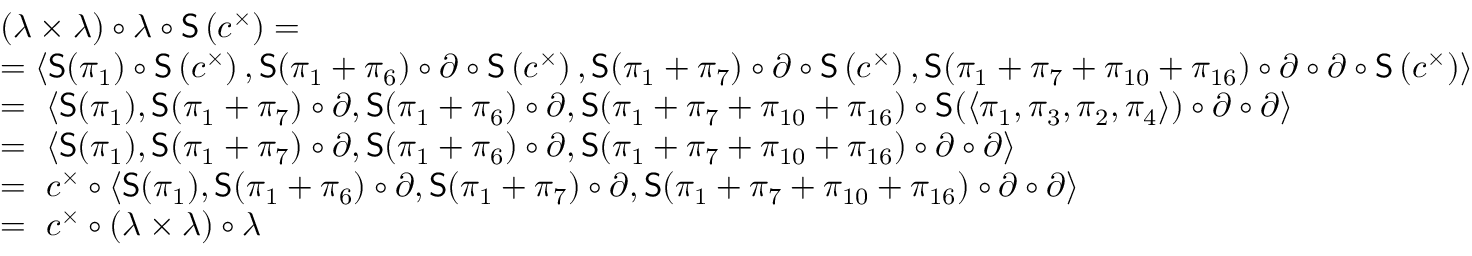<formula> <loc_0><loc_0><loc_500><loc_500>\begin{array} { r l } & { ( \lambda \times \lambda ) \circ \lambda \circ S \left ( c ^ { \times } \right ) = } \\ & { = \left \langle S ( \pi _ { 1 } ) \circ S \left ( c ^ { \times } \right ) , S ( \pi _ { 1 } + \pi _ { 6 } ) \circ \partial \circ S \left ( c ^ { \times } \right ) , S ( \pi _ { 1 } + \pi _ { 7 } ) \circ \partial \circ S \left ( c ^ { \times } \right ) , S ( \pi _ { 1 } + \pi _ { 7 } + \pi _ { 1 0 } + \pi _ { 1 6 } ) \circ \partial \circ \partial \circ S \left ( c ^ { \times } \right ) \right \rangle } \\ & { = \left \langle S ( \pi _ { 1 } ) , S ( \pi _ { 1 } + \pi _ { 7 } ) \circ \partial , S ( \pi _ { 1 } + \pi _ { 6 } ) \circ \partial , S ( \pi _ { 1 } + \pi _ { 7 } + \pi _ { 1 0 } + \pi _ { 1 6 } ) \circ S ( \left \langle \pi _ { 1 } , \pi _ { 3 } , \pi _ { 2 } , \pi _ { 4 } \right \rangle ) \circ \partial \circ \partial \right \rangle } \\ & { = \left \langle S ( \pi _ { 1 } ) , S ( \pi _ { 1 } + \pi _ { 7 } ) \circ \partial , S ( \pi _ { 1 } + \pi _ { 6 } ) \circ \partial , S ( \pi _ { 1 } + \pi _ { 7 } + \pi _ { 1 0 } + \pi _ { 1 6 } ) \circ \partial \circ \partial \right \rangle } \\ & { = c ^ { \times } \circ \left \langle S ( \pi _ { 1 } ) , S ( \pi _ { 1 } + \pi _ { 6 } ) \circ \partial , S ( \pi _ { 1 } + \pi _ { 7 } ) \circ \partial , S ( \pi _ { 1 } + \pi _ { 7 } + \pi _ { 1 0 } + \pi _ { 1 6 } ) \circ \partial \circ \partial \right \rangle } \\ & { = c ^ { \times } \circ ( \lambda \times \lambda ) \circ \lambda } \end{array}</formula> 